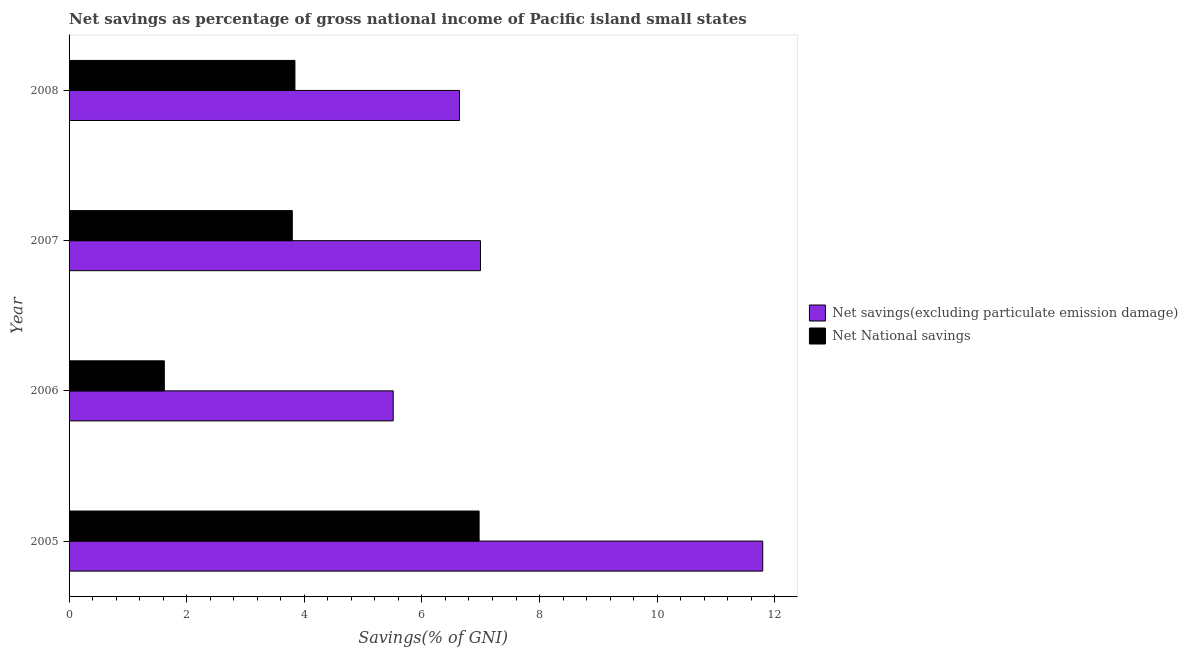Are the number of bars per tick equal to the number of legend labels?
Your response must be concise. Yes. How many bars are there on the 4th tick from the top?
Provide a short and direct response. 2. What is the label of the 4th group of bars from the top?
Offer a terse response. 2005. In how many cases, is the number of bars for a given year not equal to the number of legend labels?
Offer a very short reply. 0. What is the net savings(excluding particulate emission damage) in 2007?
Your answer should be very brief. 7. Across all years, what is the maximum net savings(excluding particulate emission damage)?
Offer a terse response. 11.8. Across all years, what is the minimum net national savings?
Offer a very short reply. 1.62. In which year was the net national savings maximum?
Keep it short and to the point. 2005. What is the total net national savings in the graph?
Your answer should be very brief. 16.23. What is the difference between the net national savings in 2007 and that in 2008?
Provide a short and direct response. -0.04. What is the difference between the net savings(excluding particulate emission damage) in 2008 and the net national savings in 2007?
Your answer should be compact. 2.84. What is the average net national savings per year?
Keep it short and to the point. 4.06. In the year 2006, what is the difference between the net national savings and net savings(excluding particulate emission damage)?
Give a very brief answer. -3.89. What is the ratio of the net savings(excluding particulate emission damage) in 2007 to that in 2008?
Provide a succinct answer. 1.05. Is the difference between the net national savings in 2007 and 2008 greater than the difference between the net savings(excluding particulate emission damage) in 2007 and 2008?
Your answer should be compact. No. What is the difference between the highest and the second highest net savings(excluding particulate emission damage)?
Offer a very short reply. 4.8. What is the difference between the highest and the lowest net national savings?
Give a very brief answer. 5.35. In how many years, is the net national savings greater than the average net national savings taken over all years?
Make the answer very short. 1. Is the sum of the net savings(excluding particulate emission damage) in 2007 and 2008 greater than the maximum net national savings across all years?
Make the answer very short. Yes. What does the 1st bar from the top in 2006 represents?
Keep it short and to the point. Net National savings. What does the 1st bar from the bottom in 2007 represents?
Provide a succinct answer. Net savings(excluding particulate emission damage). Are all the bars in the graph horizontal?
Keep it short and to the point. Yes. What is the difference between two consecutive major ticks on the X-axis?
Offer a very short reply. 2. Are the values on the major ticks of X-axis written in scientific E-notation?
Offer a very short reply. No. Does the graph contain grids?
Keep it short and to the point. No. How many legend labels are there?
Offer a very short reply. 2. How are the legend labels stacked?
Give a very brief answer. Vertical. What is the title of the graph?
Give a very brief answer. Net savings as percentage of gross national income of Pacific island small states. Does "Food and tobacco" appear as one of the legend labels in the graph?
Provide a short and direct response. No. What is the label or title of the X-axis?
Keep it short and to the point. Savings(% of GNI). What is the Savings(% of GNI) of Net savings(excluding particulate emission damage) in 2005?
Ensure brevity in your answer.  11.8. What is the Savings(% of GNI) of Net National savings in 2005?
Your response must be concise. 6.97. What is the Savings(% of GNI) of Net savings(excluding particulate emission damage) in 2006?
Ensure brevity in your answer.  5.51. What is the Savings(% of GNI) of Net National savings in 2006?
Offer a very short reply. 1.62. What is the Savings(% of GNI) in Net savings(excluding particulate emission damage) in 2007?
Your answer should be very brief. 7. What is the Savings(% of GNI) in Net National savings in 2007?
Ensure brevity in your answer.  3.8. What is the Savings(% of GNI) in Net savings(excluding particulate emission damage) in 2008?
Keep it short and to the point. 6.64. What is the Savings(% of GNI) of Net National savings in 2008?
Your answer should be compact. 3.84. Across all years, what is the maximum Savings(% of GNI) of Net savings(excluding particulate emission damage)?
Your answer should be very brief. 11.8. Across all years, what is the maximum Savings(% of GNI) in Net National savings?
Offer a terse response. 6.97. Across all years, what is the minimum Savings(% of GNI) in Net savings(excluding particulate emission damage)?
Give a very brief answer. 5.51. Across all years, what is the minimum Savings(% of GNI) in Net National savings?
Offer a very short reply. 1.62. What is the total Savings(% of GNI) of Net savings(excluding particulate emission damage) in the graph?
Provide a short and direct response. 30.94. What is the total Savings(% of GNI) of Net National savings in the graph?
Your response must be concise. 16.23. What is the difference between the Savings(% of GNI) in Net savings(excluding particulate emission damage) in 2005 and that in 2006?
Keep it short and to the point. 6.28. What is the difference between the Savings(% of GNI) in Net National savings in 2005 and that in 2006?
Provide a succinct answer. 5.35. What is the difference between the Savings(% of GNI) of Net savings(excluding particulate emission damage) in 2005 and that in 2007?
Ensure brevity in your answer.  4.8. What is the difference between the Savings(% of GNI) of Net National savings in 2005 and that in 2007?
Keep it short and to the point. 3.18. What is the difference between the Savings(% of GNI) in Net savings(excluding particulate emission damage) in 2005 and that in 2008?
Your answer should be compact. 5.16. What is the difference between the Savings(% of GNI) of Net National savings in 2005 and that in 2008?
Your answer should be very brief. 3.13. What is the difference between the Savings(% of GNI) in Net savings(excluding particulate emission damage) in 2006 and that in 2007?
Ensure brevity in your answer.  -1.48. What is the difference between the Savings(% of GNI) in Net National savings in 2006 and that in 2007?
Keep it short and to the point. -2.18. What is the difference between the Savings(% of GNI) of Net savings(excluding particulate emission damage) in 2006 and that in 2008?
Provide a short and direct response. -1.13. What is the difference between the Savings(% of GNI) in Net National savings in 2006 and that in 2008?
Offer a very short reply. -2.22. What is the difference between the Savings(% of GNI) of Net savings(excluding particulate emission damage) in 2007 and that in 2008?
Offer a terse response. 0.36. What is the difference between the Savings(% of GNI) in Net National savings in 2007 and that in 2008?
Keep it short and to the point. -0.04. What is the difference between the Savings(% of GNI) of Net savings(excluding particulate emission damage) in 2005 and the Savings(% of GNI) of Net National savings in 2006?
Your answer should be very brief. 10.18. What is the difference between the Savings(% of GNI) of Net savings(excluding particulate emission damage) in 2005 and the Savings(% of GNI) of Net National savings in 2007?
Keep it short and to the point. 8. What is the difference between the Savings(% of GNI) in Net savings(excluding particulate emission damage) in 2005 and the Savings(% of GNI) in Net National savings in 2008?
Keep it short and to the point. 7.95. What is the difference between the Savings(% of GNI) in Net savings(excluding particulate emission damage) in 2006 and the Savings(% of GNI) in Net National savings in 2007?
Provide a succinct answer. 1.72. What is the difference between the Savings(% of GNI) of Net savings(excluding particulate emission damage) in 2006 and the Savings(% of GNI) of Net National savings in 2008?
Your response must be concise. 1.67. What is the difference between the Savings(% of GNI) in Net savings(excluding particulate emission damage) in 2007 and the Savings(% of GNI) in Net National savings in 2008?
Give a very brief answer. 3.16. What is the average Savings(% of GNI) in Net savings(excluding particulate emission damage) per year?
Keep it short and to the point. 7.74. What is the average Savings(% of GNI) in Net National savings per year?
Keep it short and to the point. 4.06. In the year 2005, what is the difference between the Savings(% of GNI) in Net savings(excluding particulate emission damage) and Savings(% of GNI) in Net National savings?
Give a very brief answer. 4.82. In the year 2006, what is the difference between the Savings(% of GNI) of Net savings(excluding particulate emission damage) and Savings(% of GNI) of Net National savings?
Provide a succinct answer. 3.89. In the year 2007, what is the difference between the Savings(% of GNI) in Net savings(excluding particulate emission damage) and Savings(% of GNI) in Net National savings?
Provide a short and direct response. 3.2. In the year 2008, what is the difference between the Savings(% of GNI) of Net savings(excluding particulate emission damage) and Savings(% of GNI) of Net National savings?
Provide a short and direct response. 2.8. What is the ratio of the Savings(% of GNI) in Net savings(excluding particulate emission damage) in 2005 to that in 2006?
Offer a very short reply. 2.14. What is the ratio of the Savings(% of GNI) of Net National savings in 2005 to that in 2006?
Keep it short and to the point. 4.3. What is the ratio of the Savings(% of GNI) of Net savings(excluding particulate emission damage) in 2005 to that in 2007?
Make the answer very short. 1.69. What is the ratio of the Savings(% of GNI) of Net National savings in 2005 to that in 2007?
Make the answer very short. 1.84. What is the ratio of the Savings(% of GNI) of Net savings(excluding particulate emission damage) in 2005 to that in 2008?
Provide a short and direct response. 1.78. What is the ratio of the Savings(% of GNI) of Net National savings in 2005 to that in 2008?
Give a very brief answer. 1.82. What is the ratio of the Savings(% of GNI) of Net savings(excluding particulate emission damage) in 2006 to that in 2007?
Your answer should be very brief. 0.79. What is the ratio of the Savings(% of GNI) in Net National savings in 2006 to that in 2007?
Keep it short and to the point. 0.43. What is the ratio of the Savings(% of GNI) of Net savings(excluding particulate emission damage) in 2006 to that in 2008?
Provide a short and direct response. 0.83. What is the ratio of the Savings(% of GNI) in Net National savings in 2006 to that in 2008?
Ensure brevity in your answer.  0.42. What is the ratio of the Savings(% of GNI) of Net savings(excluding particulate emission damage) in 2007 to that in 2008?
Your answer should be compact. 1.05. What is the ratio of the Savings(% of GNI) of Net National savings in 2007 to that in 2008?
Provide a succinct answer. 0.99. What is the difference between the highest and the second highest Savings(% of GNI) in Net savings(excluding particulate emission damage)?
Give a very brief answer. 4.8. What is the difference between the highest and the second highest Savings(% of GNI) in Net National savings?
Provide a succinct answer. 3.13. What is the difference between the highest and the lowest Savings(% of GNI) of Net savings(excluding particulate emission damage)?
Your response must be concise. 6.28. What is the difference between the highest and the lowest Savings(% of GNI) in Net National savings?
Offer a very short reply. 5.35. 